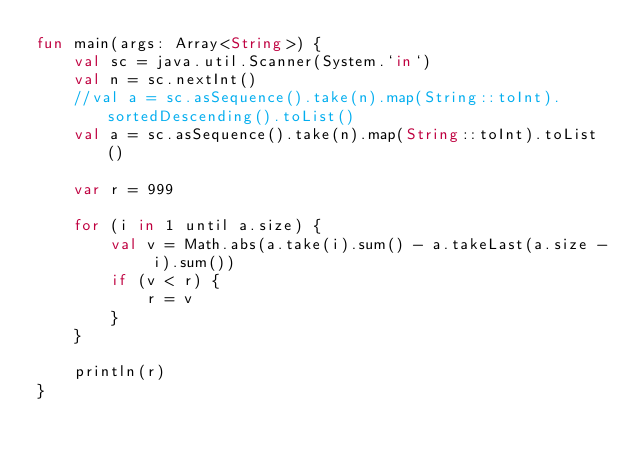<code> <loc_0><loc_0><loc_500><loc_500><_Kotlin_>fun main(args: Array<String>) {
    val sc = java.util.Scanner(System.`in`)
    val n = sc.nextInt()
    //val a = sc.asSequence().take(n).map(String::toInt).sortedDescending().toList()
    val a = sc.asSequence().take(n).map(String::toInt).toList()

    var r = 999

    for (i in 1 until a.size) {
        val v = Math.abs(a.take(i).sum() - a.takeLast(a.size - i).sum())
        if (v < r) {
            r = v
        }
    }

    println(r)
}
</code> 